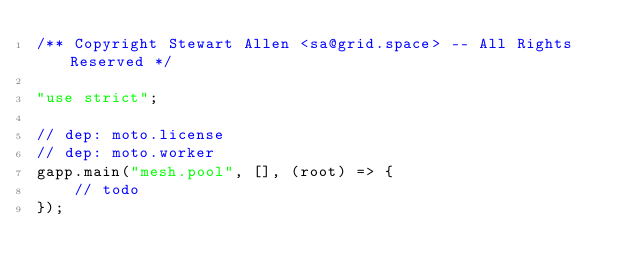<code> <loc_0><loc_0><loc_500><loc_500><_JavaScript_>/** Copyright Stewart Allen <sa@grid.space> -- All Rights Reserved */

"use strict";

// dep: moto.license
// dep: moto.worker
gapp.main("mesh.pool", [], (root) => {
    // todo
});
</code> 